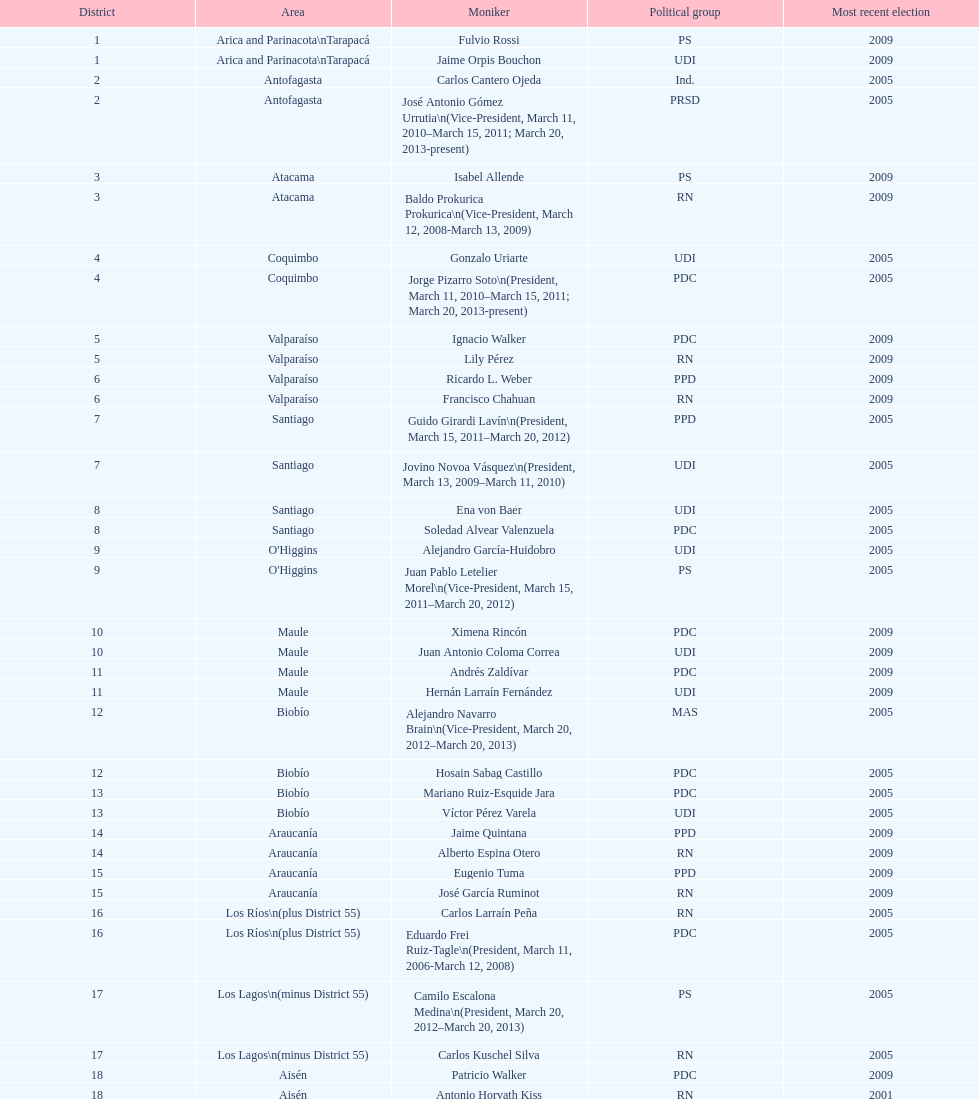What is the first name on the table? Fulvio Rossi. 